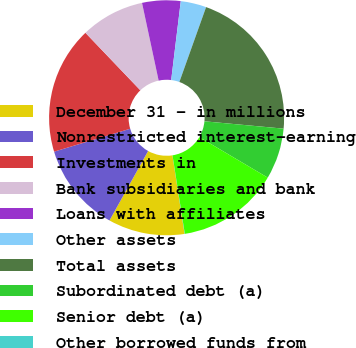Convert chart. <chart><loc_0><loc_0><loc_500><loc_500><pie_chart><fcel>December 31 - in millions<fcel>Nonrestricted interest-earning<fcel>Investments in<fcel>Bank subsidiaries and bank<fcel>Loans with affiliates<fcel>Other assets<fcel>Total assets<fcel>Subordinated debt (a)<fcel>Senior debt (a)<fcel>Other borrowed funds from<nl><fcel>10.52%<fcel>12.27%<fcel>17.52%<fcel>8.78%<fcel>5.28%<fcel>3.53%<fcel>21.02%<fcel>7.03%<fcel>14.02%<fcel>0.03%<nl></chart> 